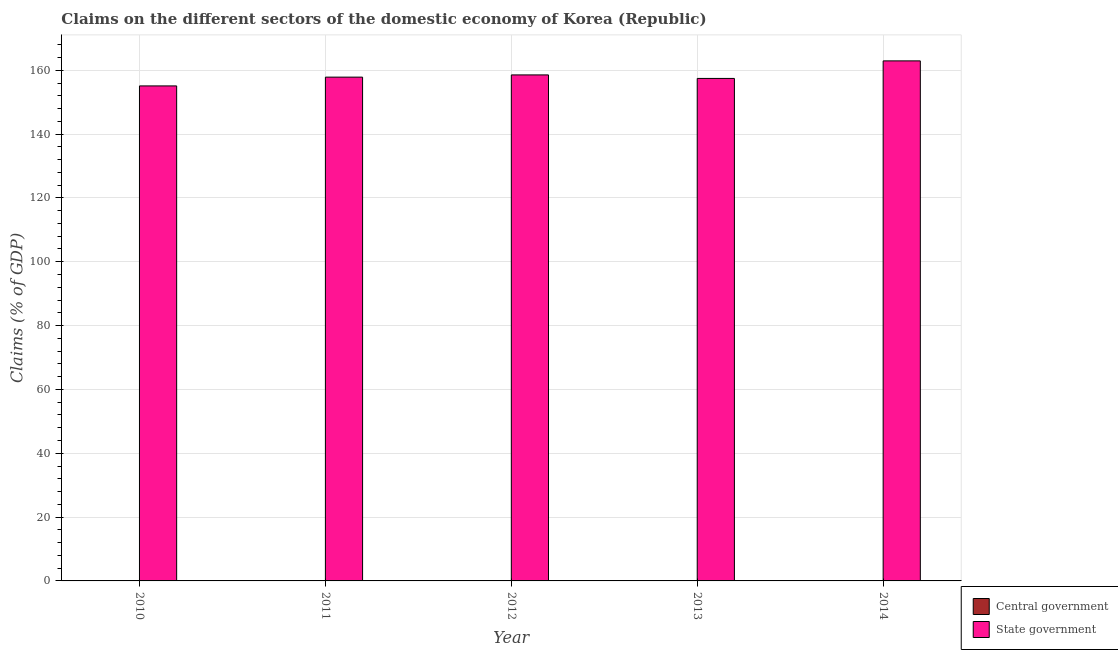How many different coloured bars are there?
Provide a short and direct response. 1. Are the number of bars per tick equal to the number of legend labels?
Your answer should be compact. No. How many bars are there on the 3rd tick from the left?
Offer a very short reply. 1. What is the label of the 1st group of bars from the left?
Give a very brief answer. 2010. What is the claims on state government in 2013?
Your answer should be very brief. 157.43. Across all years, what is the maximum claims on state government?
Offer a very short reply. 162.93. Across all years, what is the minimum claims on state government?
Provide a short and direct response. 155.09. What is the total claims on state government in the graph?
Offer a terse response. 791.83. What is the difference between the claims on state government in 2011 and that in 2012?
Offer a terse response. -0.7. What is the difference between the claims on state government in 2012 and the claims on central government in 2013?
Ensure brevity in your answer.  1.11. What is the average claims on state government per year?
Make the answer very short. 158.37. What is the ratio of the claims on state government in 2013 to that in 2014?
Your response must be concise. 0.97. What is the difference between the highest and the second highest claims on state government?
Ensure brevity in your answer.  4.4. What is the difference between the highest and the lowest claims on state government?
Offer a terse response. 7.84. In how many years, is the claims on central government greater than the average claims on central government taken over all years?
Provide a succinct answer. 0. Are all the bars in the graph horizontal?
Give a very brief answer. No. What is the difference between two consecutive major ticks on the Y-axis?
Make the answer very short. 20. Are the values on the major ticks of Y-axis written in scientific E-notation?
Provide a short and direct response. No. Does the graph contain grids?
Your answer should be compact. Yes. Where does the legend appear in the graph?
Offer a terse response. Bottom right. How are the legend labels stacked?
Your answer should be very brief. Vertical. What is the title of the graph?
Provide a succinct answer. Claims on the different sectors of the domestic economy of Korea (Republic). Does "Lowest 10% of population" appear as one of the legend labels in the graph?
Your answer should be compact. No. What is the label or title of the X-axis?
Keep it short and to the point. Year. What is the label or title of the Y-axis?
Offer a terse response. Claims (% of GDP). What is the Claims (% of GDP) in State government in 2010?
Make the answer very short. 155.09. What is the Claims (% of GDP) of State government in 2011?
Ensure brevity in your answer.  157.84. What is the Claims (% of GDP) in State government in 2012?
Provide a short and direct response. 158.54. What is the Claims (% of GDP) in State government in 2013?
Keep it short and to the point. 157.43. What is the Claims (% of GDP) of State government in 2014?
Give a very brief answer. 162.93. Across all years, what is the maximum Claims (% of GDP) of State government?
Offer a very short reply. 162.93. Across all years, what is the minimum Claims (% of GDP) of State government?
Make the answer very short. 155.09. What is the total Claims (% of GDP) of State government in the graph?
Your answer should be very brief. 791.83. What is the difference between the Claims (% of GDP) in State government in 2010 and that in 2011?
Keep it short and to the point. -2.75. What is the difference between the Claims (% of GDP) of State government in 2010 and that in 2012?
Keep it short and to the point. -3.45. What is the difference between the Claims (% of GDP) of State government in 2010 and that in 2013?
Provide a short and direct response. -2.34. What is the difference between the Claims (% of GDP) of State government in 2010 and that in 2014?
Give a very brief answer. -7.84. What is the difference between the Claims (% of GDP) of State government in 2011 and that in 2012?
Make the answer very short. -0.7. What is the difference between the Claims (% of GDP) in State government in 2011 and that in 2013?
Your response must be concise. 0.41. What is the difference between the Claims (% of GDP) in State government in 2011 and that in 2014?
Your response must be concise. -5.09. What is the difference between the Claims (% of GDP) in State government in 2012 and that in 2013?
Provide a succinct answer. 1.11. What is the difference between the Claims (% of GDP) of State government in 2012 and that in 2014?
Offer a terse response. -4.4. What is the difference between the Claims (% of GDP) of State government in 2013 and that in 2014?
Your response must be concise. -5.5. What is the average Claims (% of GDP) of State government per year?
Your response must be concise. 158.37. What is the ratio of the Claims (% of GDP) of State government in 2010 to that in 2011?
Give a very brief answer. 0.98. What is the ratio of the Claims (% of GDP) in State government in 2010 to that in 2012?
Provide a short and direct response. 0.98. What is the ratio of the Claims (% of GDP) of State government in 2010 to that in 2013?
Provide a succinct answer. 0.99. What is the ratio of the Claims (% of GDP) of State government in 2010 to that in 2014?
Give a very brief answer. 0.95. What is the ratio of the Claims (% of GDP) of State government in 2011 to that in 2013?
Provide a succinct answer. 1. What is the ratio of the Claims (% of GDP) in State government in 2011 to that in 2014?
Your answer should be compact. 0.97. What is the ratio of the Claims (% of GDP) of State government in 2013 to that in 2014?
Your answer should be compact. 0.97. What is the difference between the highest and the second highest Claims (% of GDP) of State government?
Your response must be concise. 4.4. What is the difference between the highest and the lowest Claims (% of GDP) of State government?
Your answer should be very brief. 7.84. 